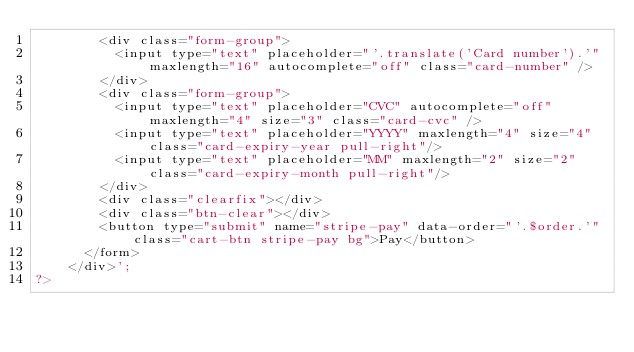<code> <loc_0><loc_0><loc_500><loc_500><_PHP_>				<div class="form-group">
					<input type="text" placeholder="'.translate('Card number').'" maxlength="16" autocomplete="off" class="card-number" />
				</div>
				<div class="form-group">
					<input type="text" placeholder="CVC" autocomplete="off" maxlength="4" size="3" class="card-cvc" />
					<input type="text" placeholder="YYYY" maxlength="4" size="4" class="card-expiry-year pull-right"/>
					<input type="text" placeholder="MM" maxlength="2" size="2" class="card-expiry-month pull-right"/>
				</div>
				<div class="clearfix"></div>
				<div class="btn-clear"></div>
				<button type="submit" name="stripe-pay" data-order="'.$order.'" class="cart-btn stripe-pay bg">Pay</button>
			</form>
		</div>';
?></code> 